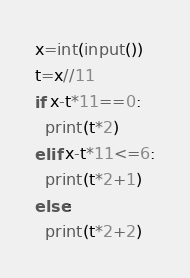Convert code to text. <code><loc_0><loc_0><loc_500><loc_500><_Python_>x=int(input())
t=x//11
if x-t*11==0:
  print(t*2)
elif x-t*11<=6:
  print(t*2+1)
else:
  print(t*2+2)</code> 